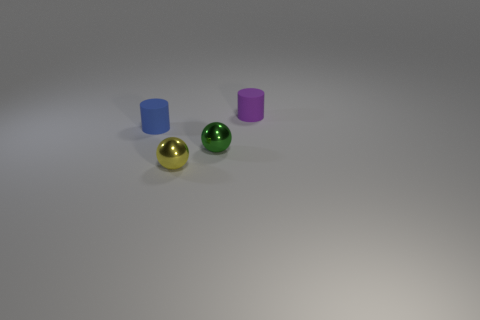How many things are to the right of the tiny blue matte cylinder and behind the green shiny thing?
Your answer should be compact. 1. Are the cylinder that is to the left of the purple matte cylinder and the small yellow thing made of the same material?
Provide a succinct answer. No. There is a tiny matte object right of the matte cylinder on the left side of the rubber cylinder on the right side of the small yellow thing; what shape is it?
Your response must be concise. Cylinder. Are there an equal number of balls that are behind the tiny green ball and small green metallic spheres that are in front of the small yellow ball?
Provide a short and direct response. Yes. What color is the rubber cylinder that is the same size as the purple rubber thing?
Your answer should be very brief. Blue. What number of tiny objects are purple objects or yellow metallic spheres?
Your answer should be very brief. 2. What is the material of the object that is left of the tiny green metallic sphere and behind the tiny green object?
Your response must be concise. Rubber. There is a matte thing that is in front of the purple thing; does it have the same shape as the small metal object that is behind the yellow metal thing?
Provide a succinct answer. No. How many things are metal spheres on the left side of the tiny green metal thing or green things?
Offer a terse response. 2. Is the green shiny sphere the same size as the purple matte object?
Keep it short and to the point. Yes. 